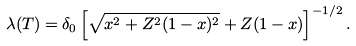<formula> <loc_0><loc_0><loc_500><loc_500>\lambda ( T ) = \delta _ { 0 } \left [ \sqrt { x ^ { 2 } + Z ^ { 2 } ( 1 - x ) ^ { 2 } } + Z ( 1 - x ) \right ] ^ { - 1 / 2 } .</formula> 